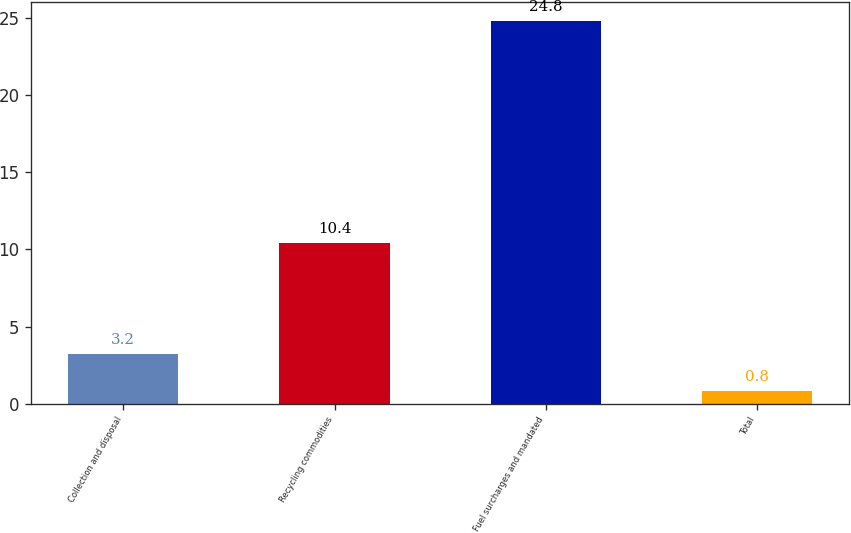<chart> <loc_0><loc_0><loc_500><loc_500><bar_chart><fcel>Collection and disposal<fcel>Recycling commodities<fcel>Fuel surcharges and mandated<fcel>Total<nl><fcel>3.2<fcel>10.4<fcel>24.8<fcel>0.8<nl></chart> 